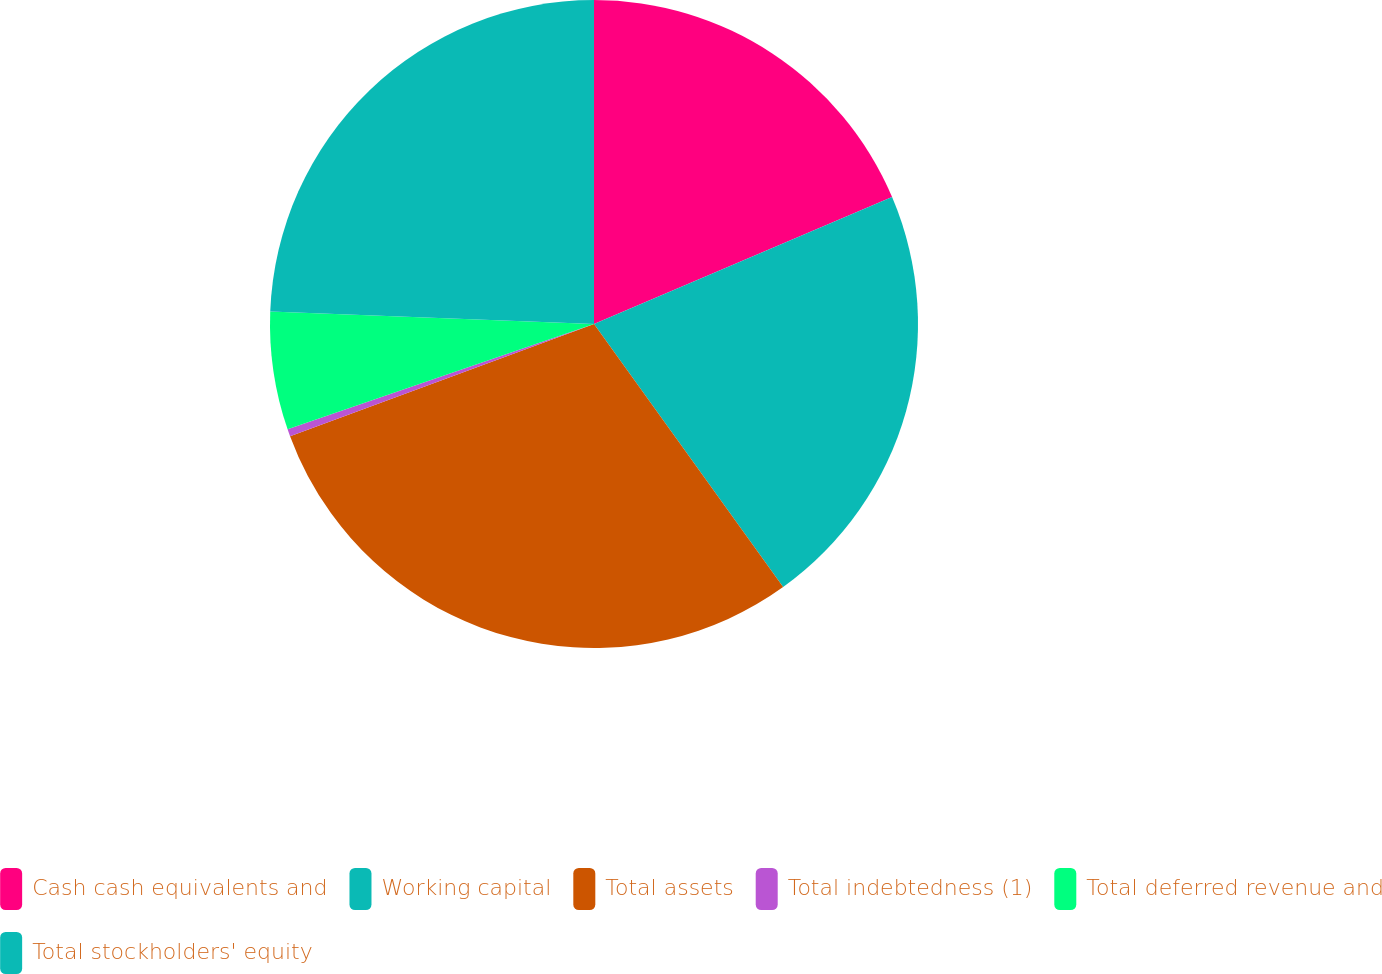Convert chart to OTSL. <chart><loc_0><loc_0><loc_500><loc_500><pie_chart><fcel>Cash cash equivalents and<fcel>Working capital<fcel>Total assets<fcel>Total indebtedness (1)<fcel>Total deferred revenue and<fcel>Total stockholders' equity<nl><fcel>18.59%<fcel>21.49%<fcel>29.29%<fcel>0.36%<fcel>5.89%<fcel>24.38%<nl></chart> 